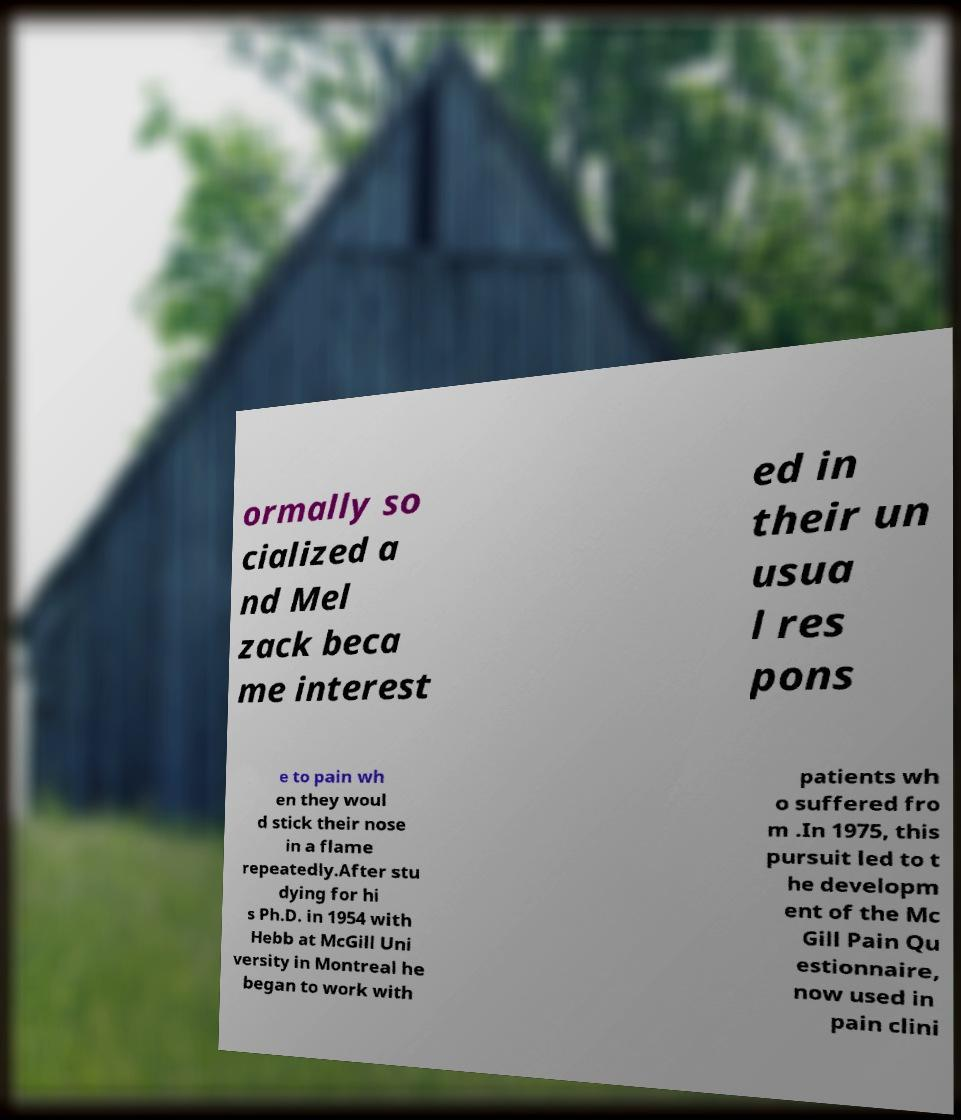For documentation purposes, I need the text within this image transcribed. Could you provide that? ormally so cialized a nd Mel zack beca me interest ed in their un usua l res pons e to pain wh en they woul d stick their nose in a flame repeatedly.After stu dying for hi s Ph.D. in 1954 with Hebb at McGill Uni versity in Montreal he began to work with patients wh o suffered fro m .In 1975, this pursuit led to t he developm ent of the Mc Gill Pain Qu estionnaire, now used in pain clini 